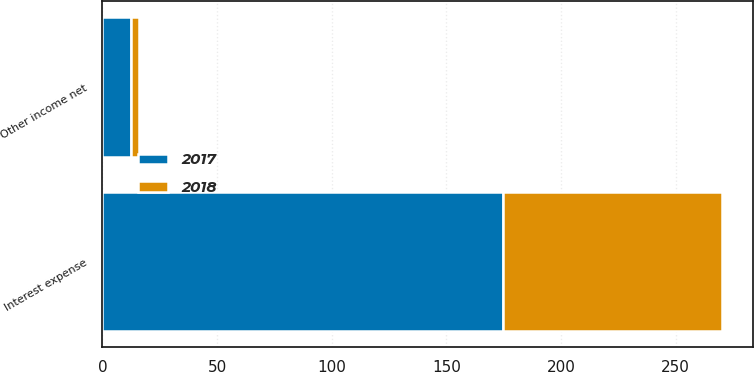Convert chart to OTSL. <chart><loc_0><loc_0><loc_500><loc_500><stacked_bar_chart><ecel><fcel>Interest expense<fcel>Other income net<nl><fcel>2017<fcel>174.6<fcel>12.6<nl><fcel>2018<fcel>95.7<fcel>3.5<nl></chart> 